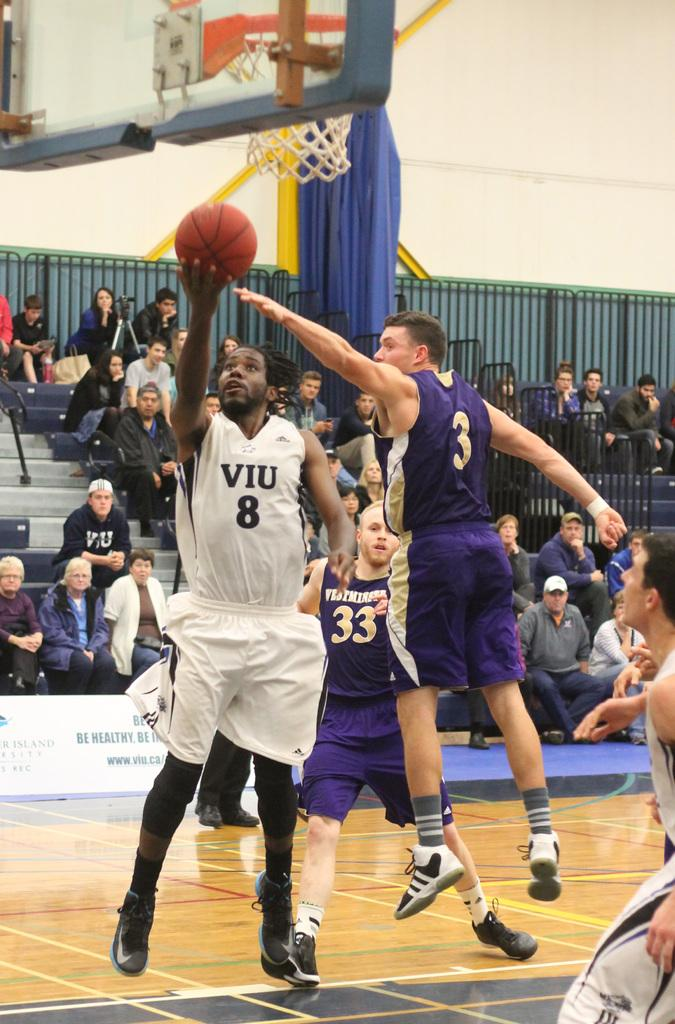<image>
Create a compact narrative representing the image presented. Basketball team members with white jersey and the letters VIU making a shot. 